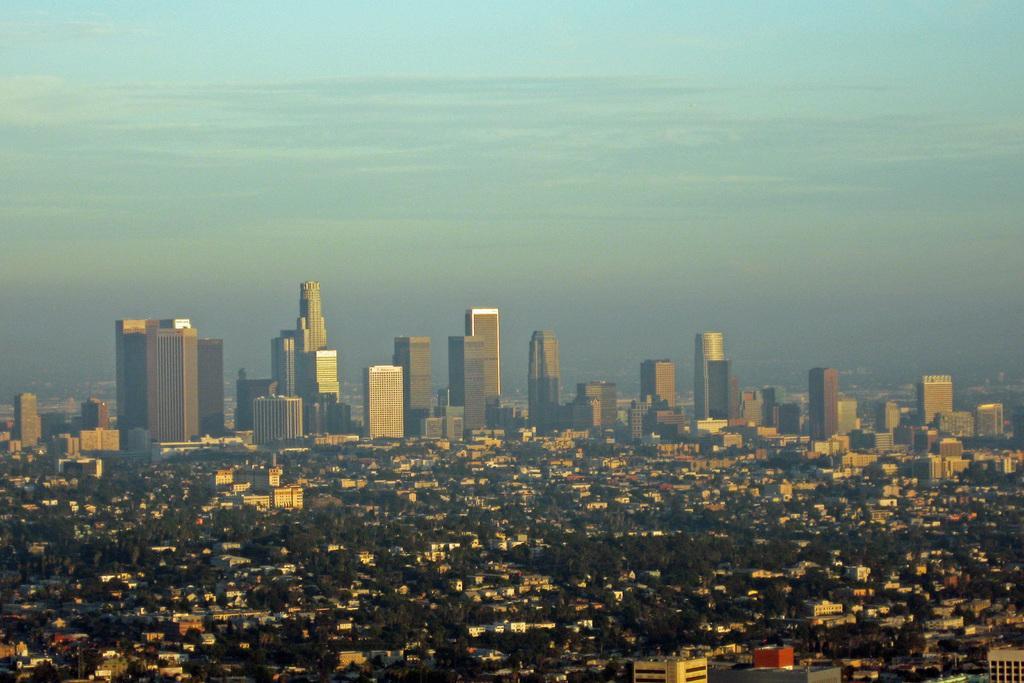In one or two sentences, can you explain what this image depicts? In this image we can see the aerial view and there are some buildings and trees and at the top we can see the sky. 